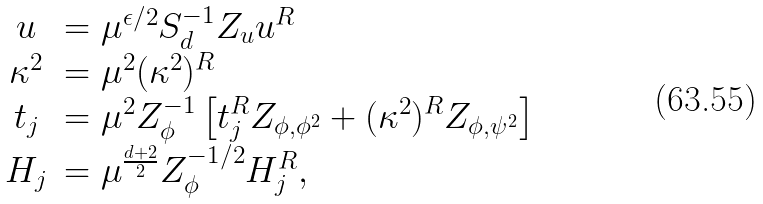<formula> <loc_0><loc_0><loc_500><loc_500>\begin{array} { c l } u & = \mu ^ { \epsilon / 2 } S _ { d } ^ { - 1 } Z _ { u } u ^ { R } \\ \kappa ^ { 2 } & = \mu ^ { 2 } ( \kappa ^ { 2 } ) ^ { R } \\ t _ { j } & = \mu ^ { 2 } { Z _ { \phi } ^ { - 1 } } \left [ t _ { j } ^ { R } Z _ { \phi , \phi ^ { 2 } } + ( \kappa ^ { 2 } ) ^ { R } Z _ { \phi , \psi ^ { 2 } } \right ] \\ H _ { j } & = \mu ^ { \frac { d + 2 } { 2 } } { Z _ { \phi } ^ { - 1 / 2 } } H _ { j } ^ { R } , \end{array}</formula> 